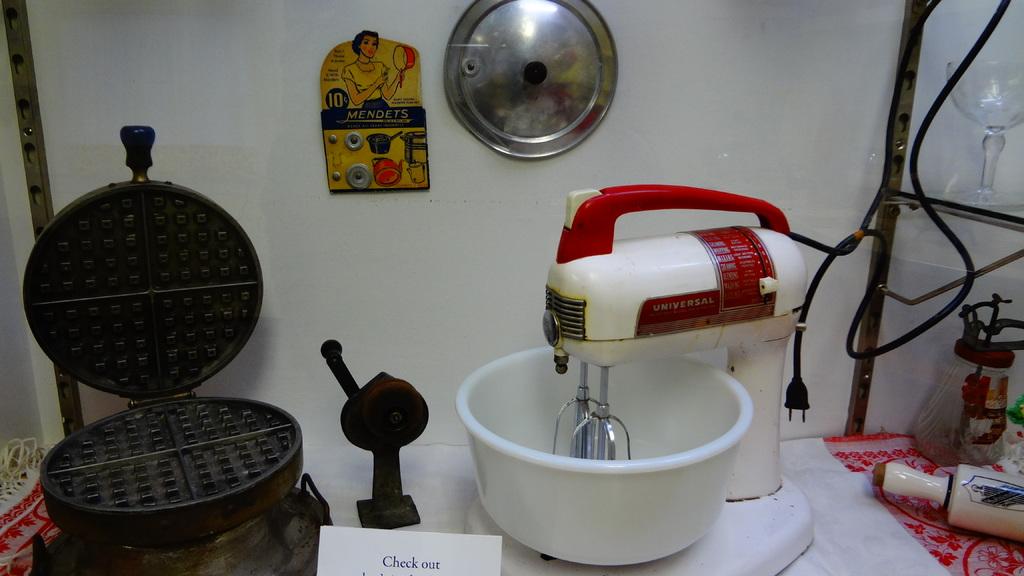What kind of mixer is that?
Give a very brief answer. Universal. What does the yellow fridge magnets say in the back?
Make the answer very short. Mendets. 